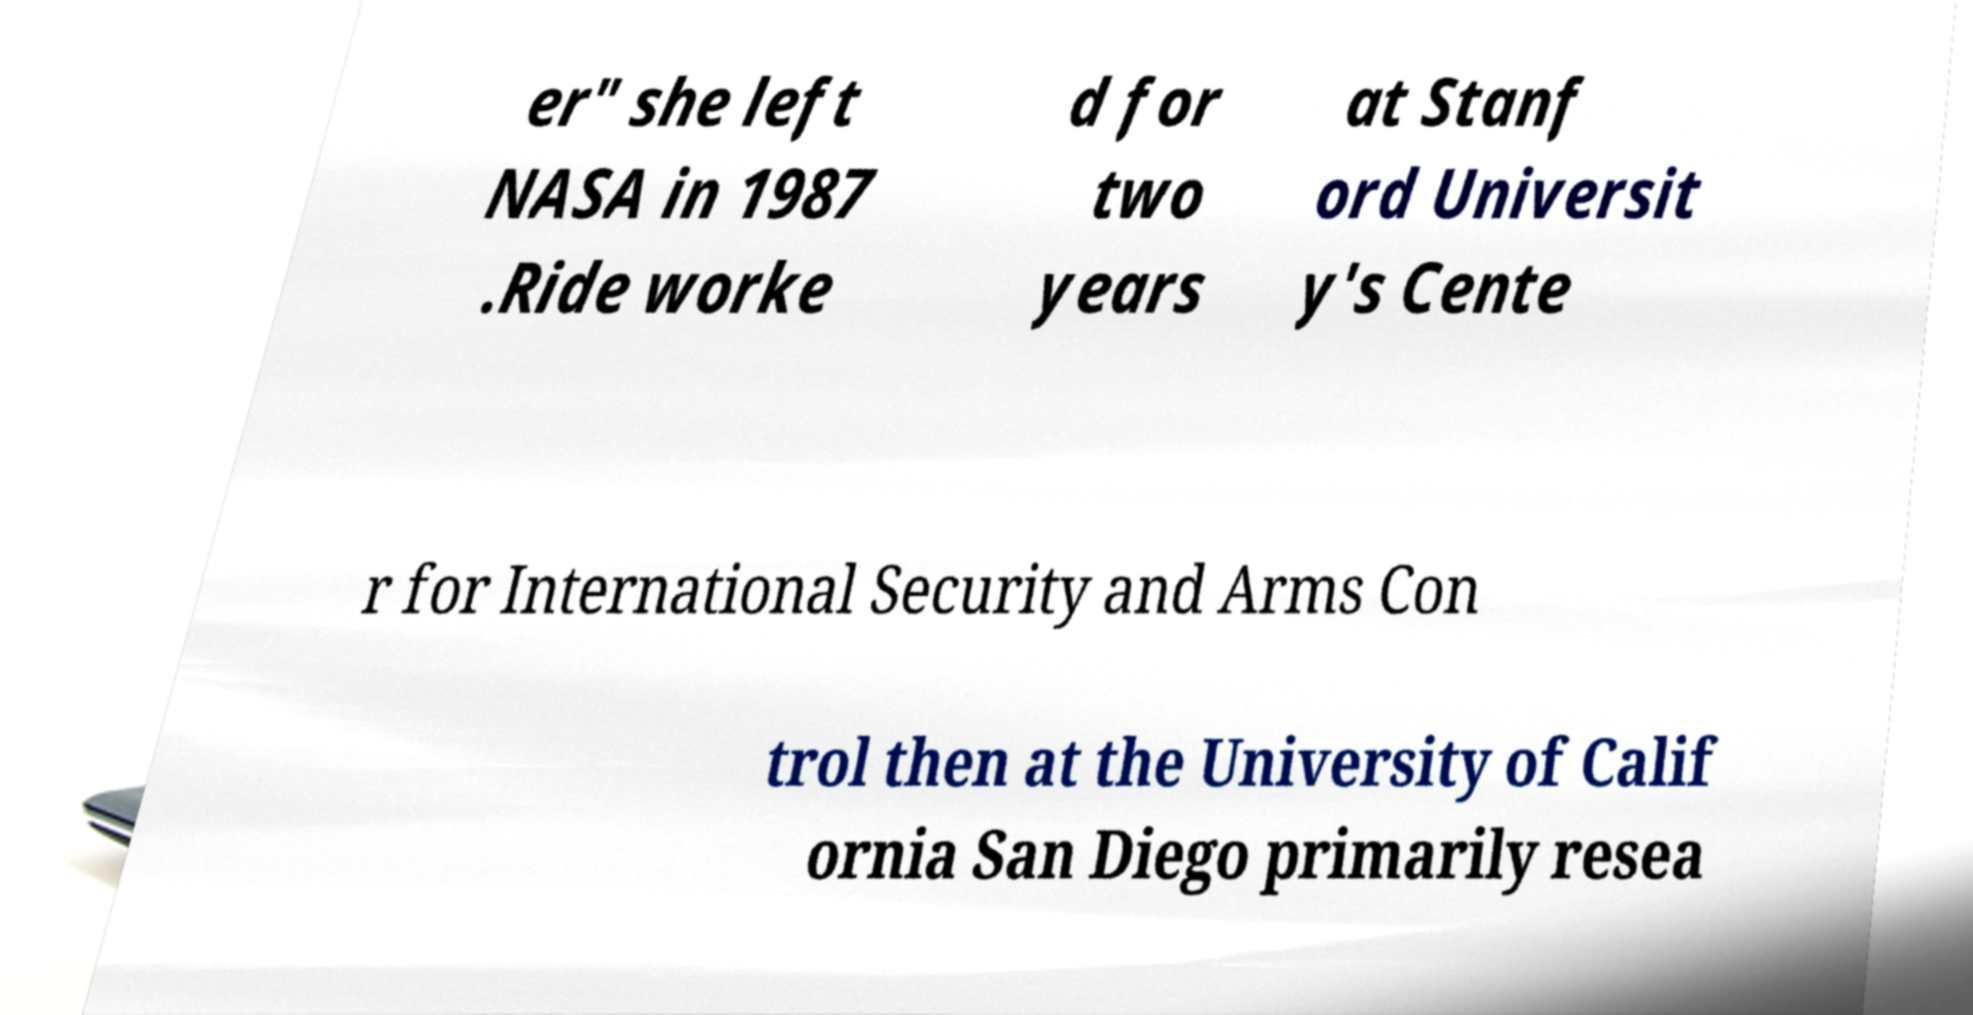Can you read and provide the text displayed in the image?This photo seems to have some interesting text. Can you extract and type it out for me? er" she left NASA in 1987 .Ride worke d for two years at Stanf ord Universit y's Cente r for International Security and Arms Con trol then at the University of Calif ornia San Diego primarily resea 